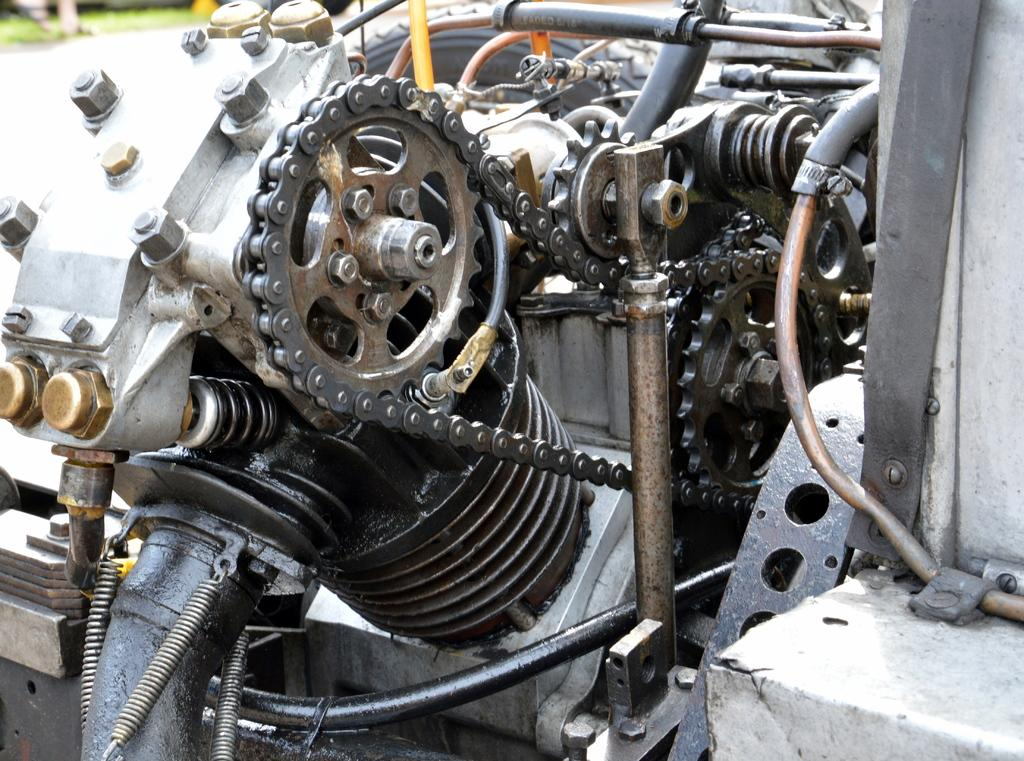What is the main subject of the image? The main subject of the image is an engine. What type of engine is it? The engine belongs to a vehicle. What is the name of the sea that the engine is transporting in the image? There is no sea or transportation depicted in the image; it only features an engine. 